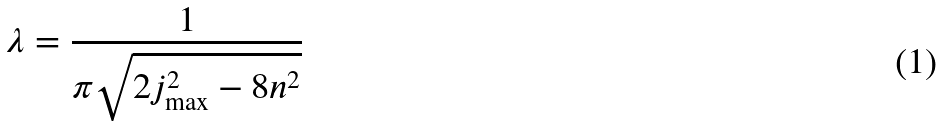Convert formula to latex. <formula><loc_0><loc_0><loc_500><loc_500>\lambda = \frac { 1 } { \pi \sqrt { 2 j _ { \max } ^ { 2 } - 8 n ^ { 2 } } }</formula> 